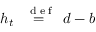Convert formula to latex. <formula><loc_0><loc_0><loc_500><loc_500>h _ { t } \stackrel { { d e f } } { = } d - b</formula> 